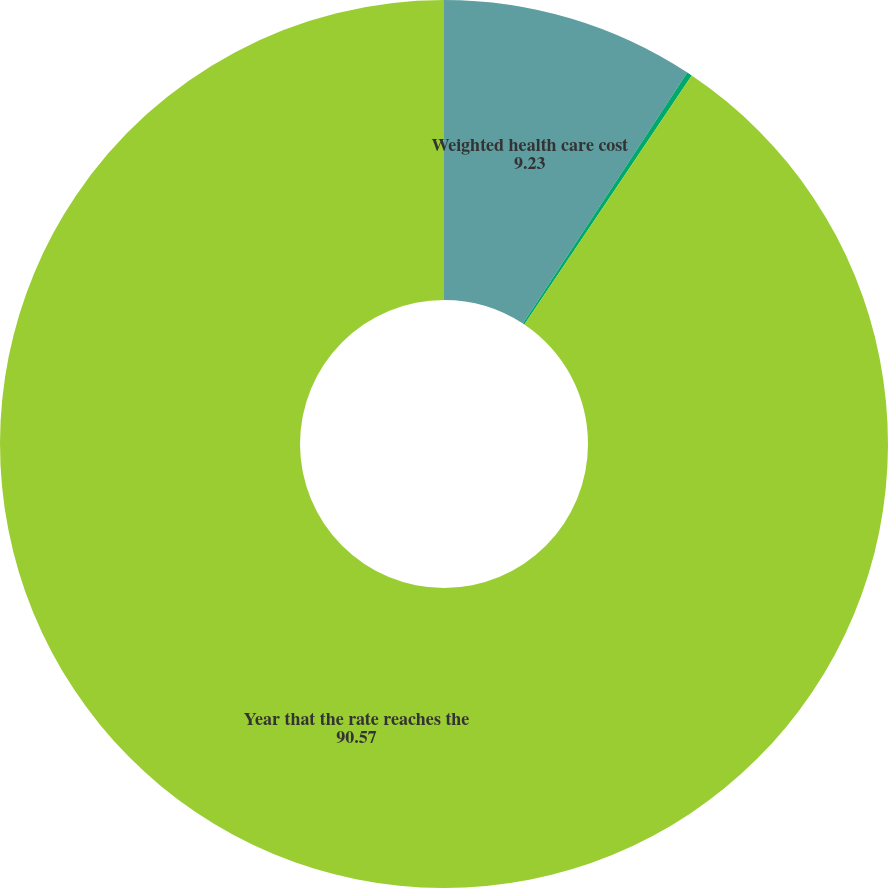<chart> <loc_0><loc_0><loc_500><loc_500><pie_chart><fcel>Weighted health care cost<fcel>Rate to which cost trend rate<fcel>Year that the rate reaches the<nl><fcel>9.23%<fcel>0.19%<fcel>90.57%<nl></chart> 